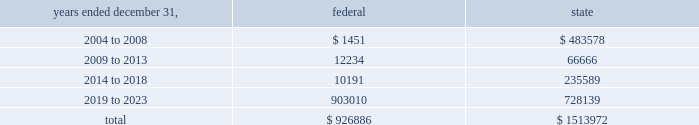American tower corporation and subsidiaries notes to consolidated financial statements 2014 ( continued ) basis step-up from corporate restructuring represents the tax effects of increasing the basis for tax purposes of certain of the company 2019s assets in conjunction with its spin-off from american radio systems corporation , its former parent company .
At december 31 , 2003 , the company had net federal and state operating loss carryforwards available to reduce future taxable income of approximately $ 0.9 billion and $ 1.5 billion , respectively .
If not utilized , the company 2019s net operating loss carryforwards expire as follows ( in thousands ) : .
Sfas no .
109 , 201caccounting for income taxes , 201d requires that companies record a valuation allowance when it is 201cmore likely than not that some portion or all of the deferred tax assets will not be realized . 201d at december 31 , 2003 , the company has provided a valuation allowance of approximately $ 156.7 million , primarily related to net state deferred tax assets , capital loss carryforwards and the lost tax benefit and costs associated with our tax refund claims .
The company has not provided a valuation allowance for the remaining net deferred tax assets , primarily its tax refund claims and federal net operating loss carryforwards , as management believes the company will be successful with its tax refund claims and have sufficient time to realize these federal net operating loss carryforwards during the twenty-year tax carryforward period .
The company intends to recover a portion of its deferred tax asset through its tax refund claims , related to certain federal net operating losses , filed during 2003 as part of a tax planning strategy implemented in 2002 .
The recoverability of its remaining net deferred tax asset has been assessed utilizing stable state ( no growth ) projections based on its current operations .
The projections show a significant decrease in depreciation and interest expense in the later years of the carryforward period as a result of a significant portion of its assets being fully depreciated during the first fifteen years of the carryforward period and debt repayments reducing interest expense .
Accordingly , the recoverability of the net deferred tax asset is not dependent on material improvements to operations , material asset sales or other non-routine transactions .
Based on its current outlook of future taxable income during the carryforward period , management believes that the net deferred tax asset will be realized .
The realization of the company 2019s deferred tax assets will be dependent upon its ability to generate approximately $ 1.0 billion in taxable income from january 1 , 2004 to december 31 , 2023 .
If the company is unable to generate sufficient taxable income in the future , or carry back losses as described above , it will be required to reduce its net deferred tax asset through a charge to income tax expense , which would result in a corresponding decrease in stockholders 2019 equity .
Depending on the resolution of the verestar bankruptcy proceedings described in note 2 , the company may be entitled to a worthless stock or bad debt deduction for its investment in verestar .
No income tax benefit has been provided for these potential deductions due to the uncertainty surrounding the bankruptcy proceedings .
13 .
Stockholders 2019 equity preferred stock as of december 31 , 2003 the company was authorized to issue up to 20.0 million shares of $ .01 par value preferred stock .
As of december 31 , 2003 and 2002 there were no preferred shares issued or outstanding. .
At december 312003 what was the percent of the total company 2019s federal net operating loss carry forwards set to expire between 2009 to 2013? 
Computations: (12234 / 926886)
Answer: 0.0132. American tower corporation and subsidiaries notes to consolidated financial statements 2014 ( continued ) basis step-up from corporate restructuring represents the tax effects of increasing the basis for tax purposes of certain of the company 2019s assets in conjunction with its spin-off from american radio systems corporation , its former parent company .
At december 31 , 2003 , the company had net federal and state operating loss carryforwards available to reduce future taxable income of approximately $ 0.9 billion and $ 1.5 billion , respectively .
If not utilized , the company 2019s net operating loss carryforwards expire as follows ( in thousands ) : .
Sfas no .
109 , 201caccounting for income taxes , 201d requires that companies record a valuation allowance when it is 201cmore likely than not that some portion or all of the deferred tax assets will not be realized . 201d at december 31 , 2003 , the company has provided a valuation allowance of approximately $ 156.7 million , primarily related to net state deferred tax assets , capital loss carryforwards and the lost tax benefit and costs associated with our tax refund claims .
The company has not provided a valuation allowance for the remaining net deferred tax assets , primarily its tax refund claims and federal net operating loss carryforwards , as management believes the company will be successful with its tax refund claims and have sufficient time to realize these federal net operating loss carryforwards during the twenty-year tax carryforward period .
The company intends to recover a portion of its deferred tax asset through its tax refund claims , related to certain federal net operating losses , filed during 2003 as part of a tax planning strategy implemented in 2002 .
The recoverability of its remaining net deferred tax asset has been assessed utilizing stable state ( no growth ) projections based on its current operations .
The projections show a significant decrease in depreciation and interest expense in the later years of the carryforward period as a result of a significant portion of its assets being fully depreciated during the first fifteen years of the carryforward period and debt repayments reducing interest expense .
Accordingly , the recoverability of the net deferred tax asset is not dependent on material improvements to operations , material asset sales or other non-routine transactions .
Based on its current outlook of future taxable income during the carryforward period , management believes that the net deferred tax asset will be realized .
The realization of the company 2019s deferred tax assets will be dependent upon its ability to generate approximately $ 1.0 billion in taxable income from january 1 , 2004 to december 31 , 2023 .
If the company is unable to generate sufficient taxable income in the future , or carry back losses as described above , it will be required to reduce its net deferred tax asset through a charge to income tax expense , which would result in a corresponding decrease in stockholders 2019 equity .
Depending on the resolution of the verestar bankruptcy proceedings described in note 2 , the company may be entitled to a worthless stock or bad debt deduction for its investment in verestar .
No income tax benefit has been provided for these potential deductions due to the uncertainty surrounding the bankruptcy proceedings .
13 .
Stockholders 2019 equity preferred stock as of december 31 , 2003 the company was authorized to issue up to 20.0 million shares of $ .01 par value preferred stock .
As of december 31 , 2003 and 2002 there were no preferred shares issued or outstanding. .
At december 31 , 2003 , what was the ratio of the company net federal operating loss carry forwards to the state? 
Computations: (0.9 / 1.5)
Answer: 0.6. 